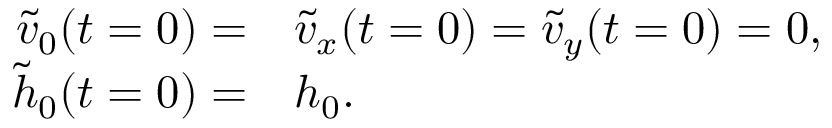Convert formula to latex. <formula><loc_0><loc_0><loc_500><loc_500>\begin{array} { r l } { \tilde { v } _ { 0 } ( t = 0 ) = } & \tilde { v } _ { x } ( t = 0 ) = \tilde { v } _ { y } ( t = 0 ) = 0 , } \\ { \tilde { h } _ { 0 } ( t = 0 ) = } & h _ { 0 } . } \end{array}</formula> 